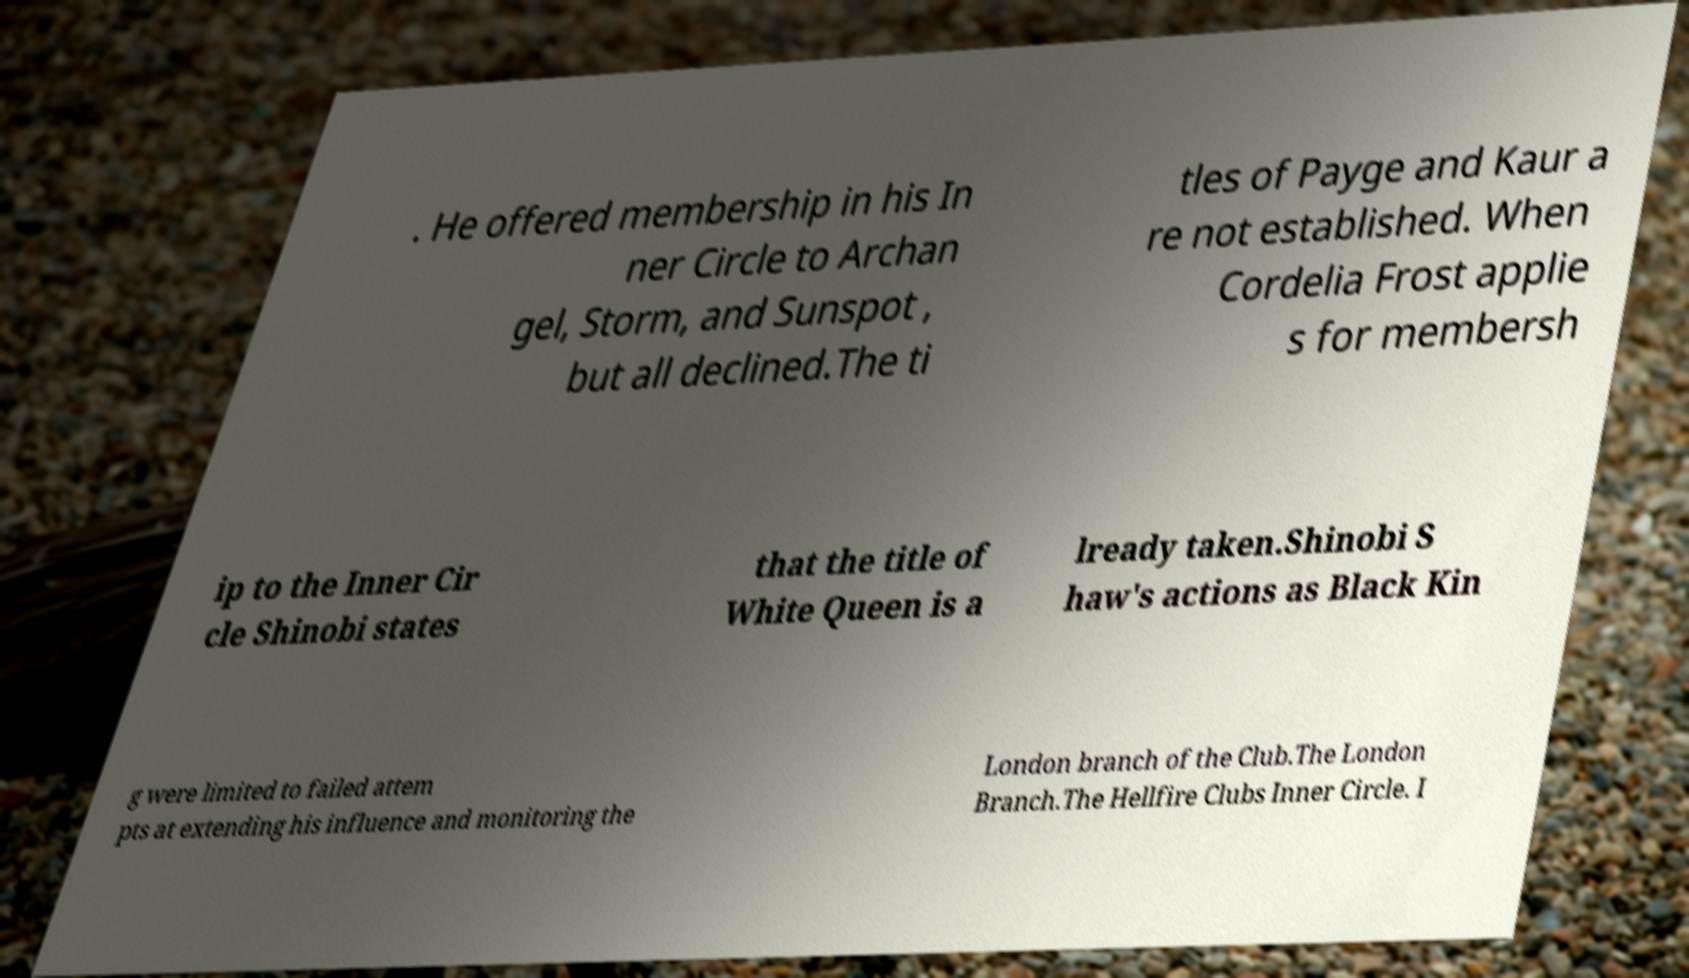I need the written content from this picture converted into text. Can you do that? . He offered membership in his In ner Circle to Archan gel, Storm, and Sunspot , but all declined.The ti tles of Payge and Kaur a re not established. When Cordelia Frost applie s for membersh ip to the Inner Cir cle Shinobi states that the title of White Queen is a lready taken.Shinobi S haw's actions as Black Kin g were limited to failed attem pts at extending his influence and monitoring the London branch of the Club.The London Branch.The Hellfire Clubs Inner Circle. I 